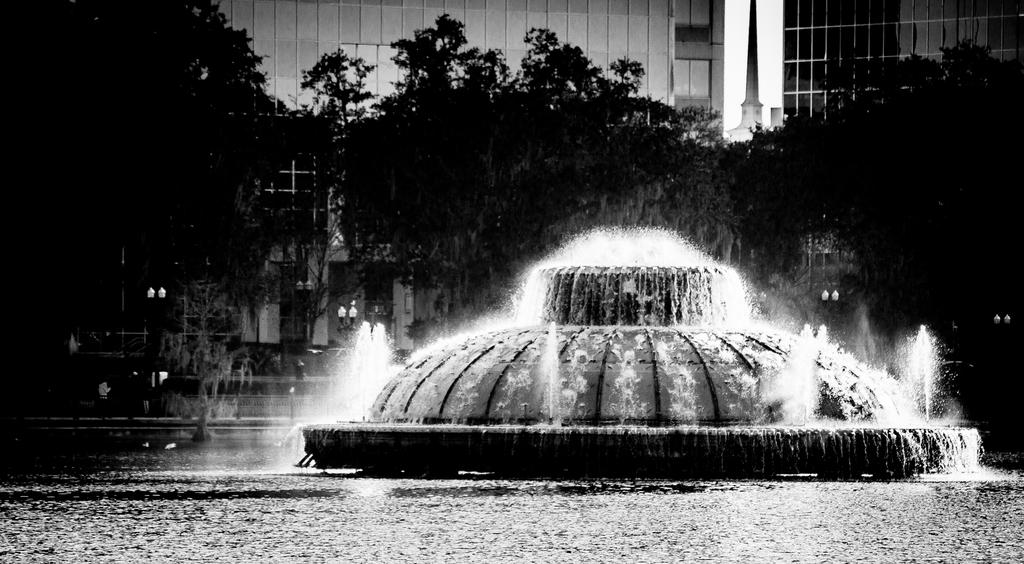What natural feature is located in the middle of the image? There are waterfalls in the middle of the image. What type of vegetation can be seen in the image? There are trees in the image. What type of man-made structures are visible in the background? In the background, there are buildings. Is there any quicksand present in the image? There is no quicksand present in the image. What is the rate of water flow in the waterfalls? The rate of water flow in the waterfalls cannot be determined from the image alone. 